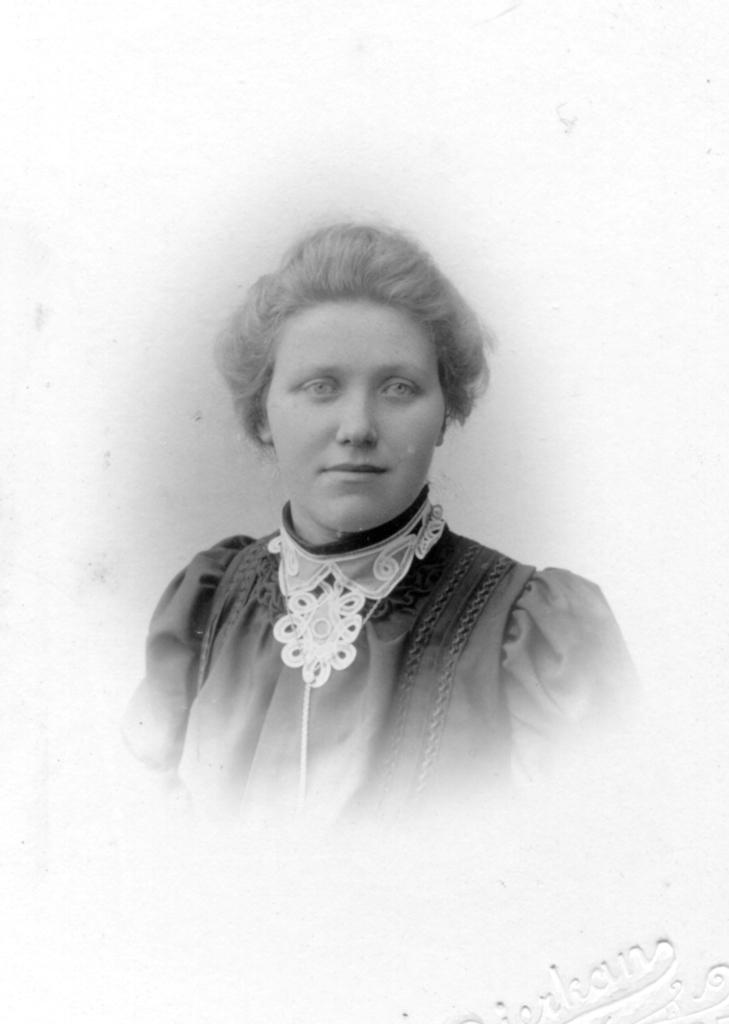Who is present in the image? There is a woman in the image. What is the woman wearing? The woman is wearing a dress. What is the color scheme of the image? The image is in black and white color. Is the woman wearing a scarf in the image? There is no mention of a scarf in the image, so it cannot be determined whether the woman is wearing one or not. 